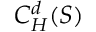<formula> <loc_0><loc_0><loc_500><loc_500>C _ { H } ^ { d } ( S )</formula> 